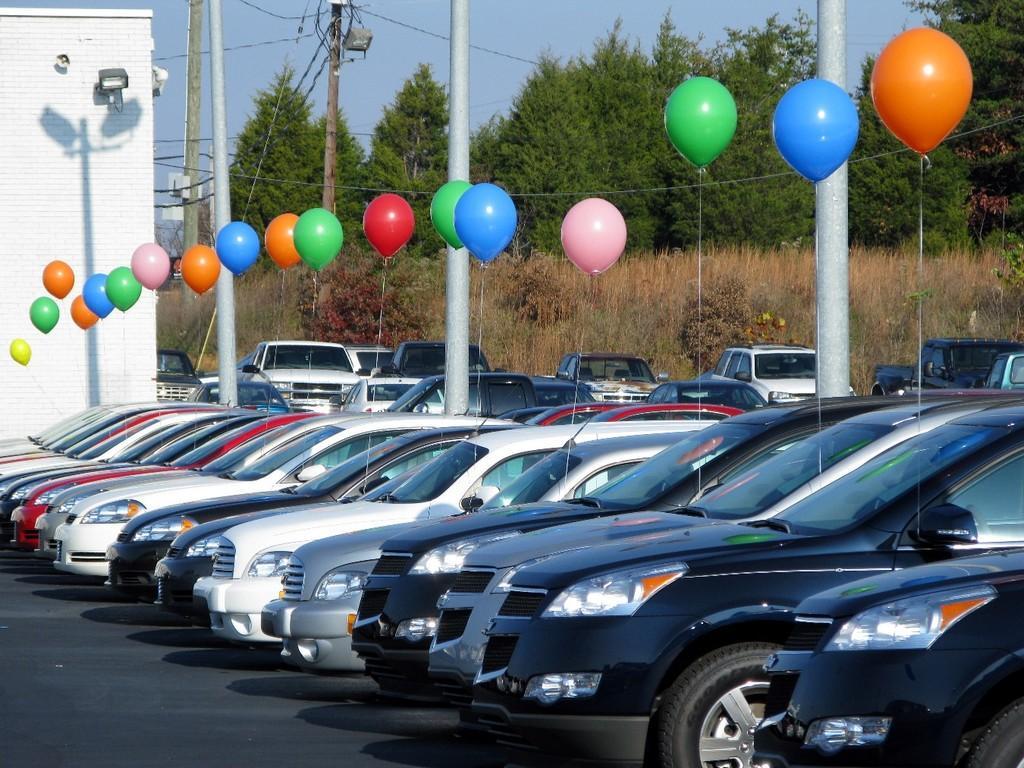How would you summarize this image in a sentence or two? In the picture these cars are parked here on the road, I can see different colors of balloons, I can see poles, wires, grass, house on the left side of the image, I can see trees and the sky in the background. 